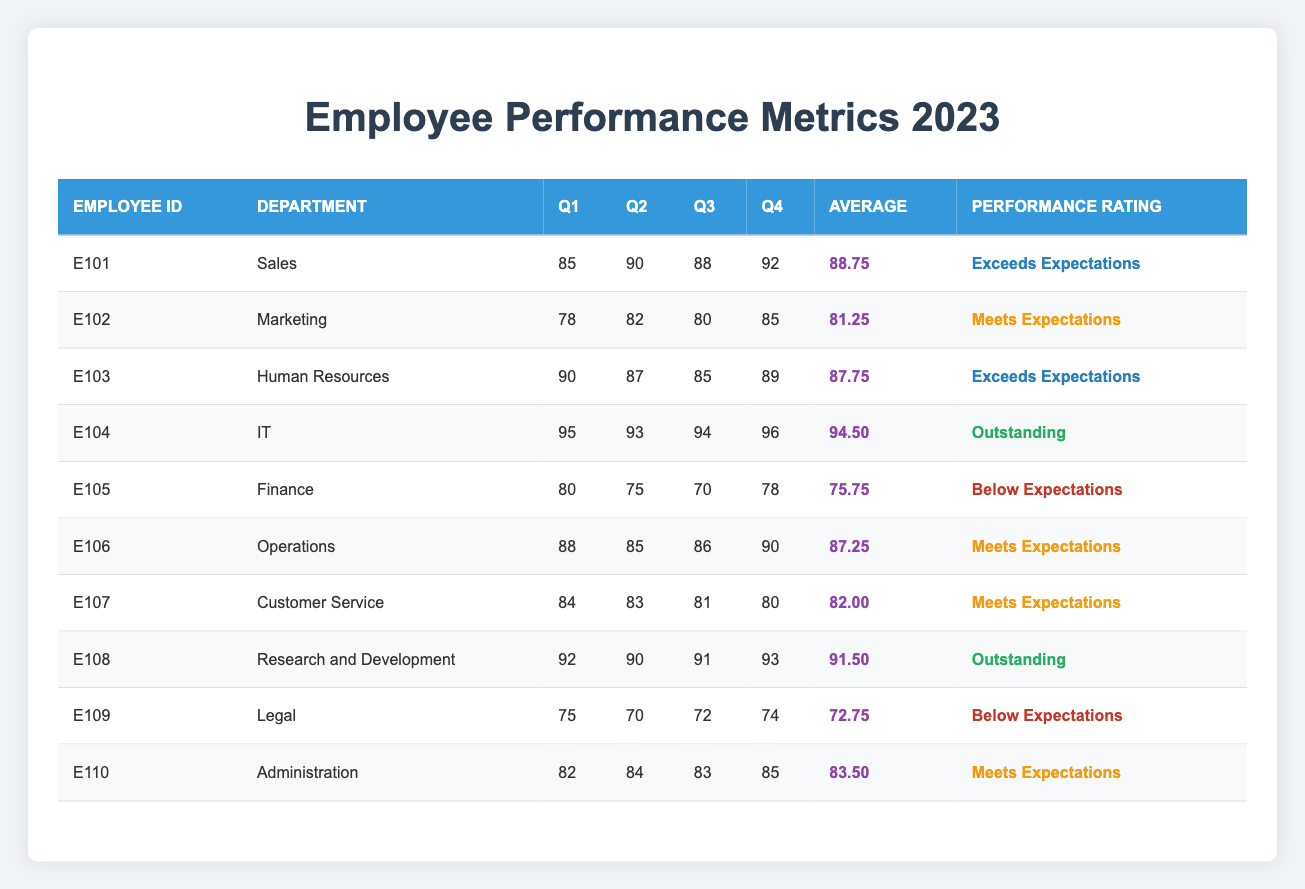What is the performance rating of the employee from the IT department? The table shows that the employee with Employee ID E104 is in the IT department, and the performance rating is noted as "Outstanding."
Answer: Outstanding Which department has the employee with the highest average score? By examining the averages, the employee from the IT department has the highest score of 94.5, making IT the department with the highest average score.
Answer: IT How many employees meet or exceed expectations based on performance ratings? There are 7 employees with ratings of "Exceeds Expectations" (3) or "Outstanding" (1) plus those marked "Meets Expectations" (3), totaling 7 employees who meet or exceed expectations.
Answer: 7 What is the average performance rating of the Finance department employee? The Finance department's employee has scores in Q1 (80), Q2 (75), Q3 (70), and Q4 (78). To find the average: (80 + 75 + 70 + 78) / 4 = 75.75
Answer: 75.75 Is there an employee from the Customer Service department who scores below expectations? The performance rating for the customer service employee (E107) is "Meets Expectations," indicating they do not score below expectations. Therefore, the answer is no.
Answer: No If the average of the Legal department employee is below 75, how many other employees do the same? The Legal department employee has an average score of 72.75, which is below 75. The Finance department employee also has a score below 75 (75.75). Hence, there are 2 employees below 75.
Answer: 2 What is the total of all the Q2 scores of employees in the table? Adding all Q2 scores: 90 (Sales) + 82 (Marketing) + 87 (HR) + 93 (IT) + 75 (Finance) + 85 (Operations) + 83 (Customer Service) + 90 (R&D) + 70 (Legal) + 84 (Administration) gives a total of  849.
Answer: 849 